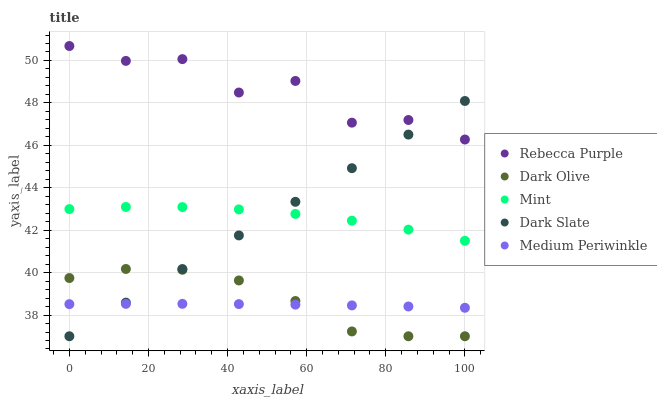Does Medium Periwinkle have the minimum area under the curve?
Answer yes or no. Yes. Does Rebecca Purple have the maximum area under the curve?
Answer yes or no. Yes. Does Dark Olive have the minimum area under the curve?
Answer yes or no. No. Does Dark Olive have the maximum area under the curve?
Answer yes or no. No. Is Dark Slate the smoothest?
Answer yes or no. Yes. Is Rebecca Purple the roughest?
Answer yes or no. Yes. Is Dark Olive the smoothest?
Answer yes or no. No. Is Dark Olive the roughest?
Answer yes or no. No. Does Dark Slate have the lowest value?
Answer yes or no. Yes. Does Mint have the lowest value?
Answer yes or no. No. Does Rebecca Purple have the highest value?
Answer yes or no. Yes. Does Dark Olive have the highest value?
Answer yes or no. No. Is Mint less than Rebecca Purple?
Answer yes or no. Yes. Is Mint greater than Medium Periwinkle?
Answer yes or no. Yes. Does Medium Periwinkle intersect Dark Olive?
Answer yes or no. Yes. Is Medium Periwinkle less than Dark Olive?
Answer yes or no. No. Is Medium Periwinkle greater than Dark Olive?
Answer yes or no. No. Does Mint intersect Rebecca Purple?
Answer yes or no. No. 